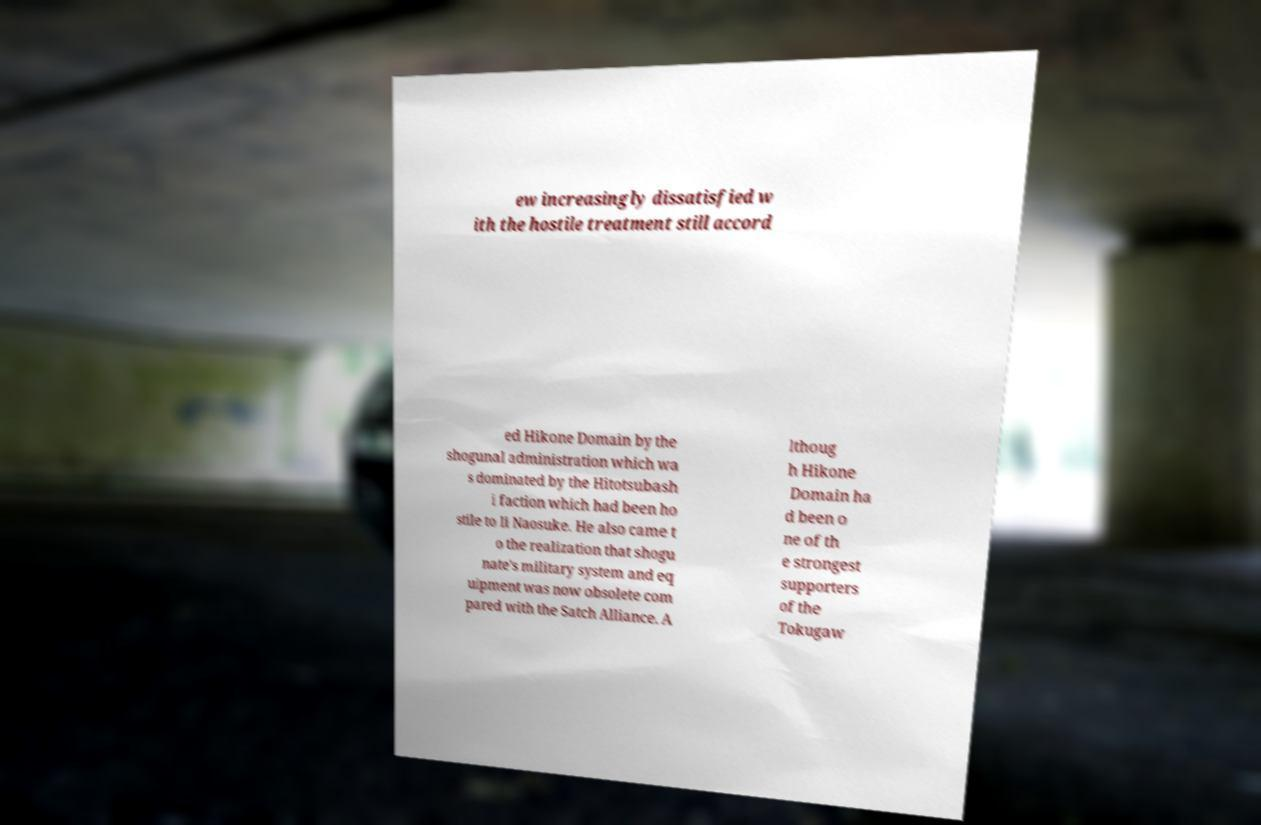Can you read and provide the text displayed in the image?This photo seems to have some interesting text. Can you extract and type it out for me? ew increasingly dissatisfied w ith the hostile treatment still accord ed Hikone Domain by the shogunal administration which wa s dominated by the Hitotsubash i faction which had been ho stile to Ii Naosuke. He also came t o the realization that shogu nate's military system and eq uipment was now obsolete com pared with the Satch Alliance. A lthoug h Hikone Domain ha d been o ne of th e strongest supporters of the Tokugaw 